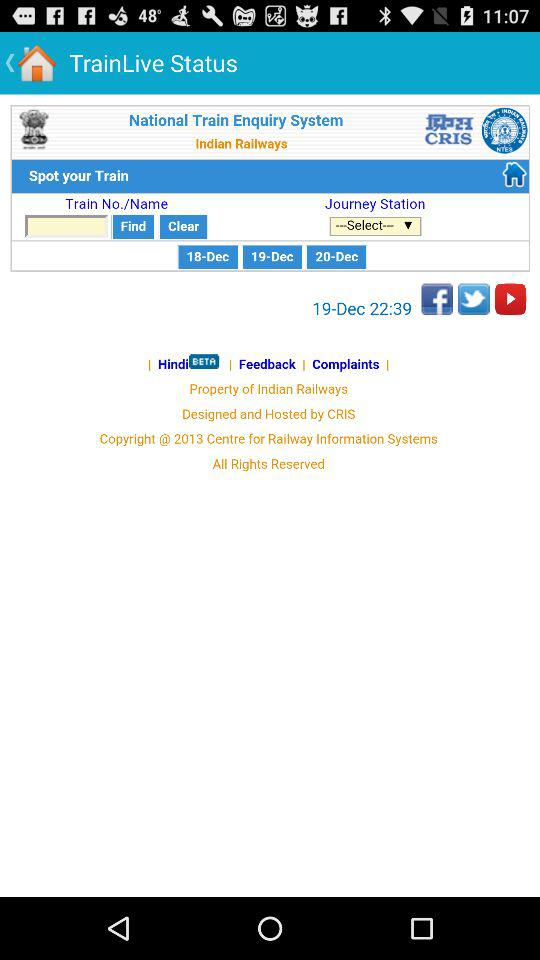What is the name of the application? The name of the application is "TrainLive Status". 